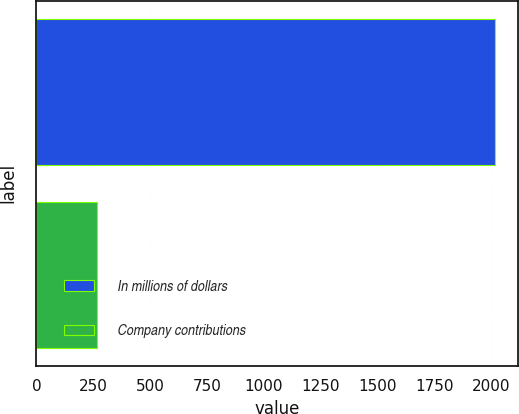Convert chart. <chart><loc_0><loc_0><loc_500><loc_500><bar_chart><fcel>In millions of dollars<fcel>Company contributions<nl><fcel>2016<fcel>268<nl></chart> 